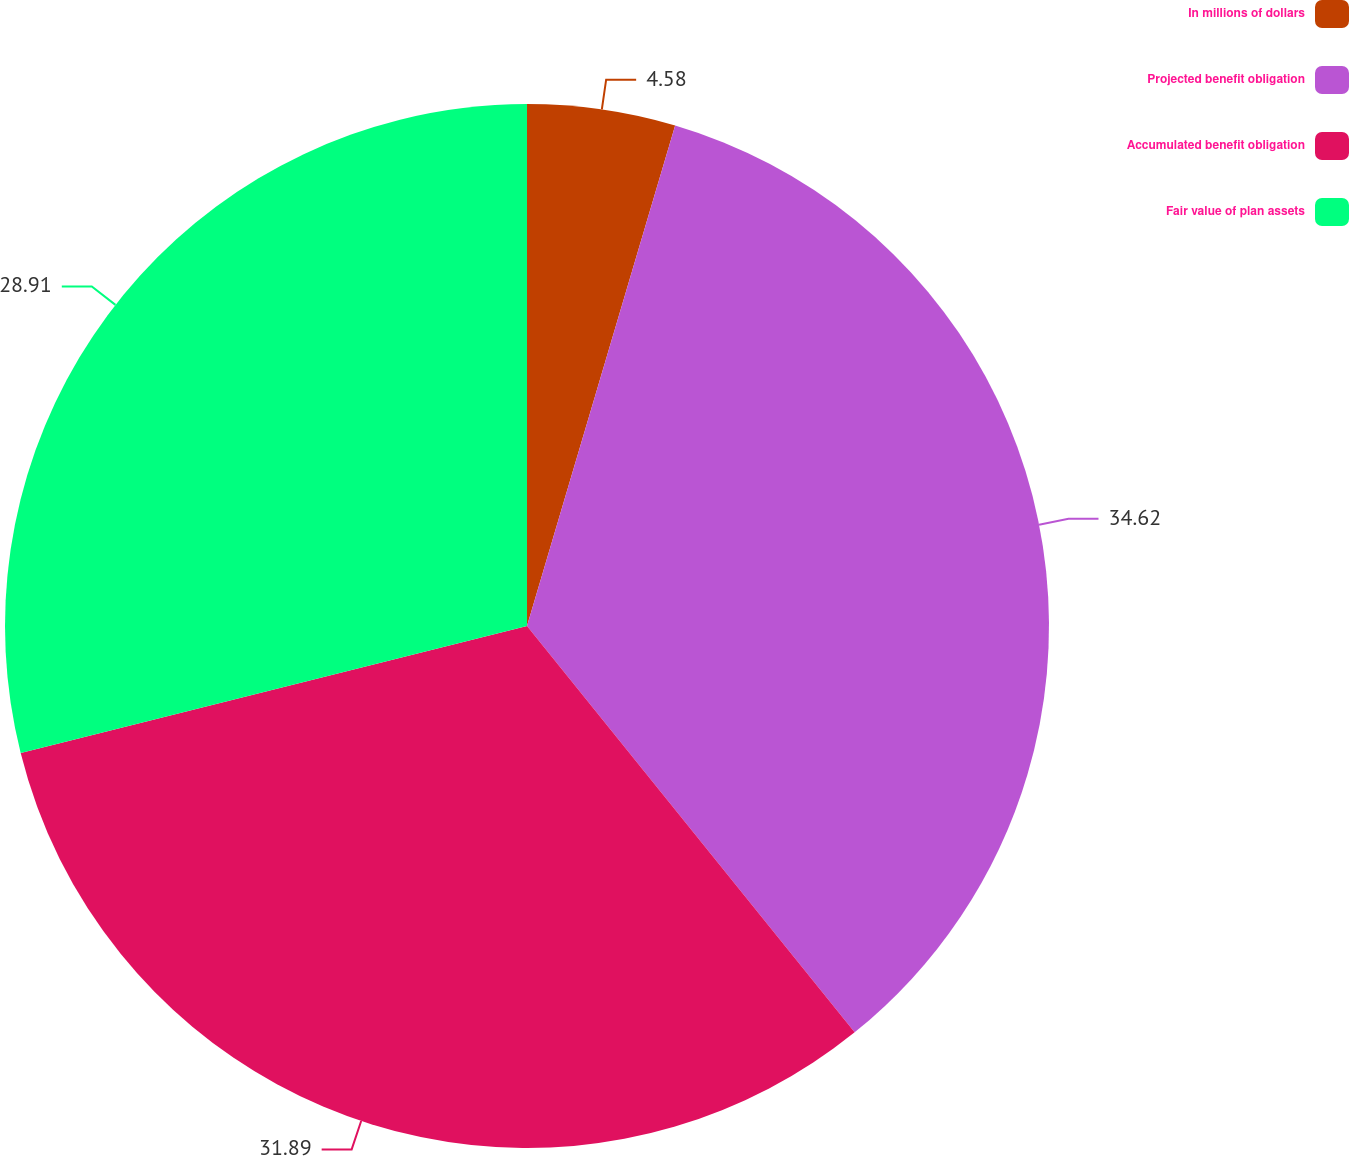Convert chart. <chart><loc_0><loc_0><loc_500><loc_500><pie_chart><fcel>In millions of dollars<fcel>Projected benefit obligation<fcel>Accumulated benefit obligation<fcel>Fair value of plan assets<nl><fcel>4.58%<fcel>34.62%<fcel>31.89%<fcel>28.91%<nl></chart> 